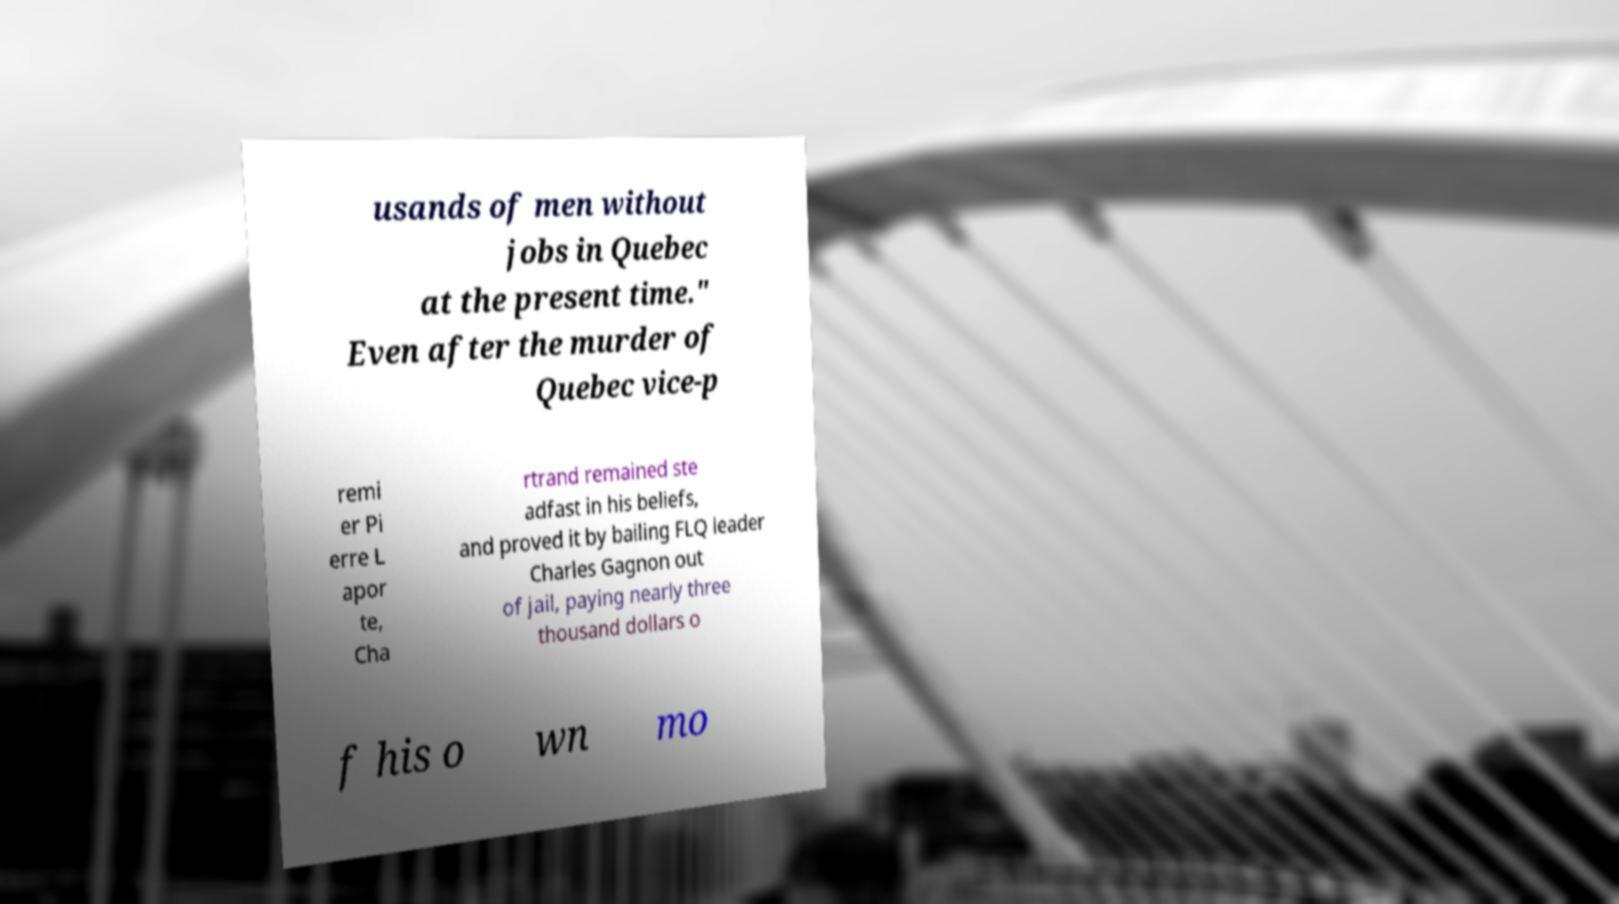Please identify and transcribe the text found in this image. usands of men without jobs in Quebec at the present time." Even after the murder of Quebec vice-p remi er Pi erre L apor te, Cha rtrand remained ste adfast in his beliefs, and proved it by bailing FLQ leader Charles Gagnon out of jail, paying nearly three thousand dollars o f his o wn mo 